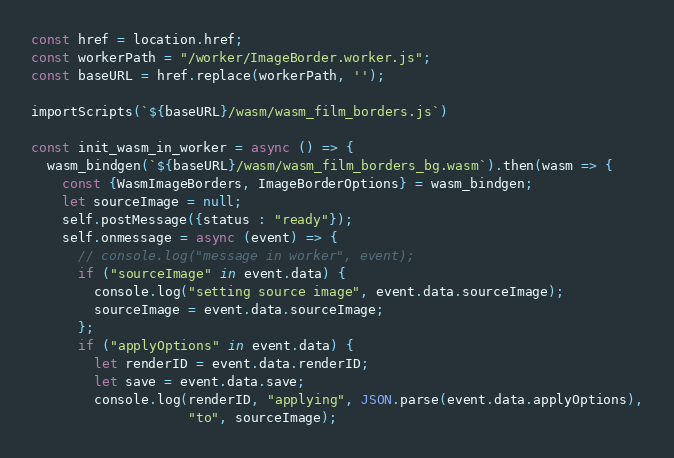Convert code to text. <code><loc_0><loc_0><loc_500><loc_500><_JavaScript_>const href = location.href;
const workerPath = "/worker/ImageBorder.worker.js";
const baseURL = href.replace(workerPath, '');

importScripts(`${baseURL}/wasm/wasm_film_borders.js`)

const init_wasm_in_worker = async () => {
  wasm_bindgen(`${baseURL}/wasm/wasm_film_borders_bg.wasm`).then(wasm => {
    const {WasmImageBorders, ImageBorderOptions} = wasm_bindgen;
    let sourceImage = null;
    self.postMessage({status : "ready"});
    self.onmessage = async (event) => {
      // console.log("message in worker", event);
      if ("sourceImage" in event.data) {
        console.log("setting source image", event.data.sourceImage);
        sourceImage = event.data.sourceImage;
      };
      if ("applyOptions" in event.data) {
        let renderID = event.data.renderID;
        let save = event.data.save;
        console.log(renderID, "applying", JSON.parse(event.data.applyOptions),
                    "to", sourceImage);</code> 